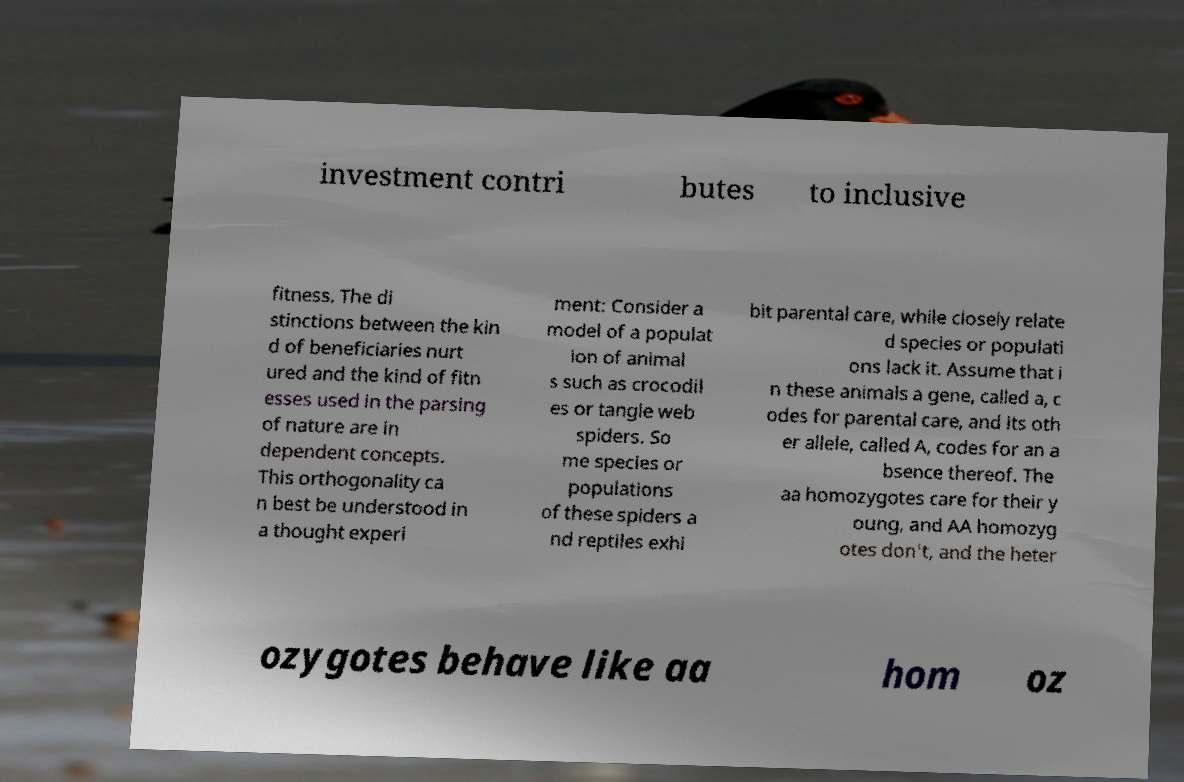I need the written content from this picture converted into text. Can you do that? investment contri butes to inclusive fitness. The di stinctions between the kin d of beneficiaries nurt ured and the kind of fitn esses used in the parsing of nature are in dependent concepts. This orthogonality ca n best be understood in a thought experi ment: Consider a model of a populat ion of animal s such as crocodil es or tangle web spiders. So me species or populations of these spiders a nd reptiles exhi bit parental care, while closely relate d species or populati ons lack it. Assume that i n these animals a gene, called a, c odes for parental care, and its oth er allele, called A, codes for an a bsence thereof. The aa homozygotes care for their y oung, and AA homozyg otes don't, and the heter ozygotes behave like aa hom oz 